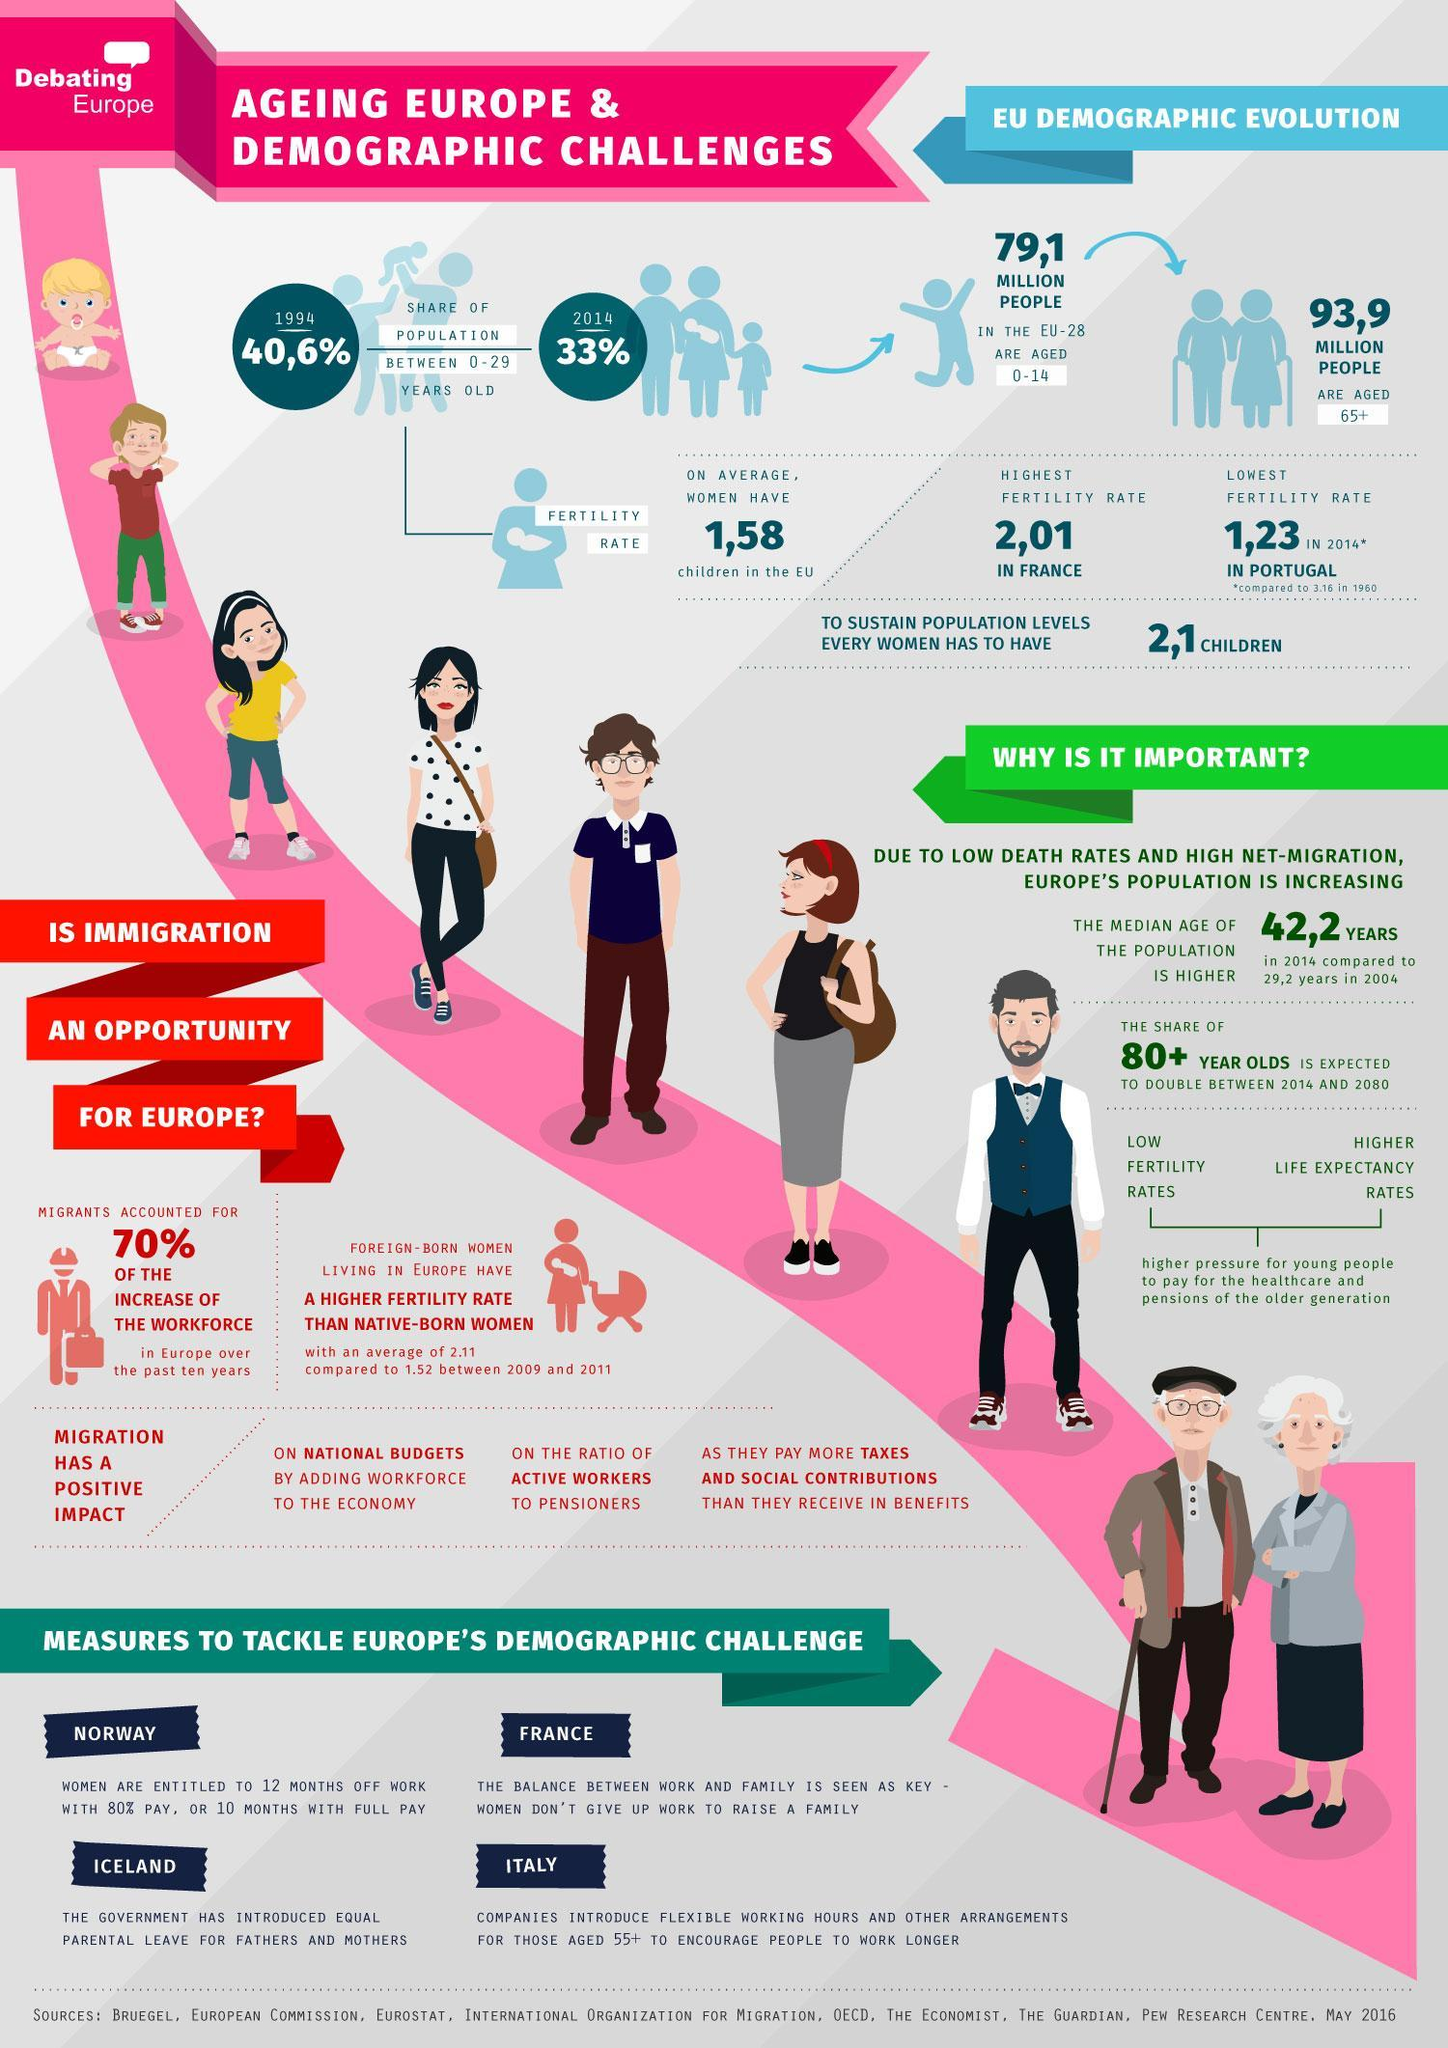Which country has the lowest fertility rate?
Answer the question with a short phrase. Portugal Which country has the highest fertility rate? France 